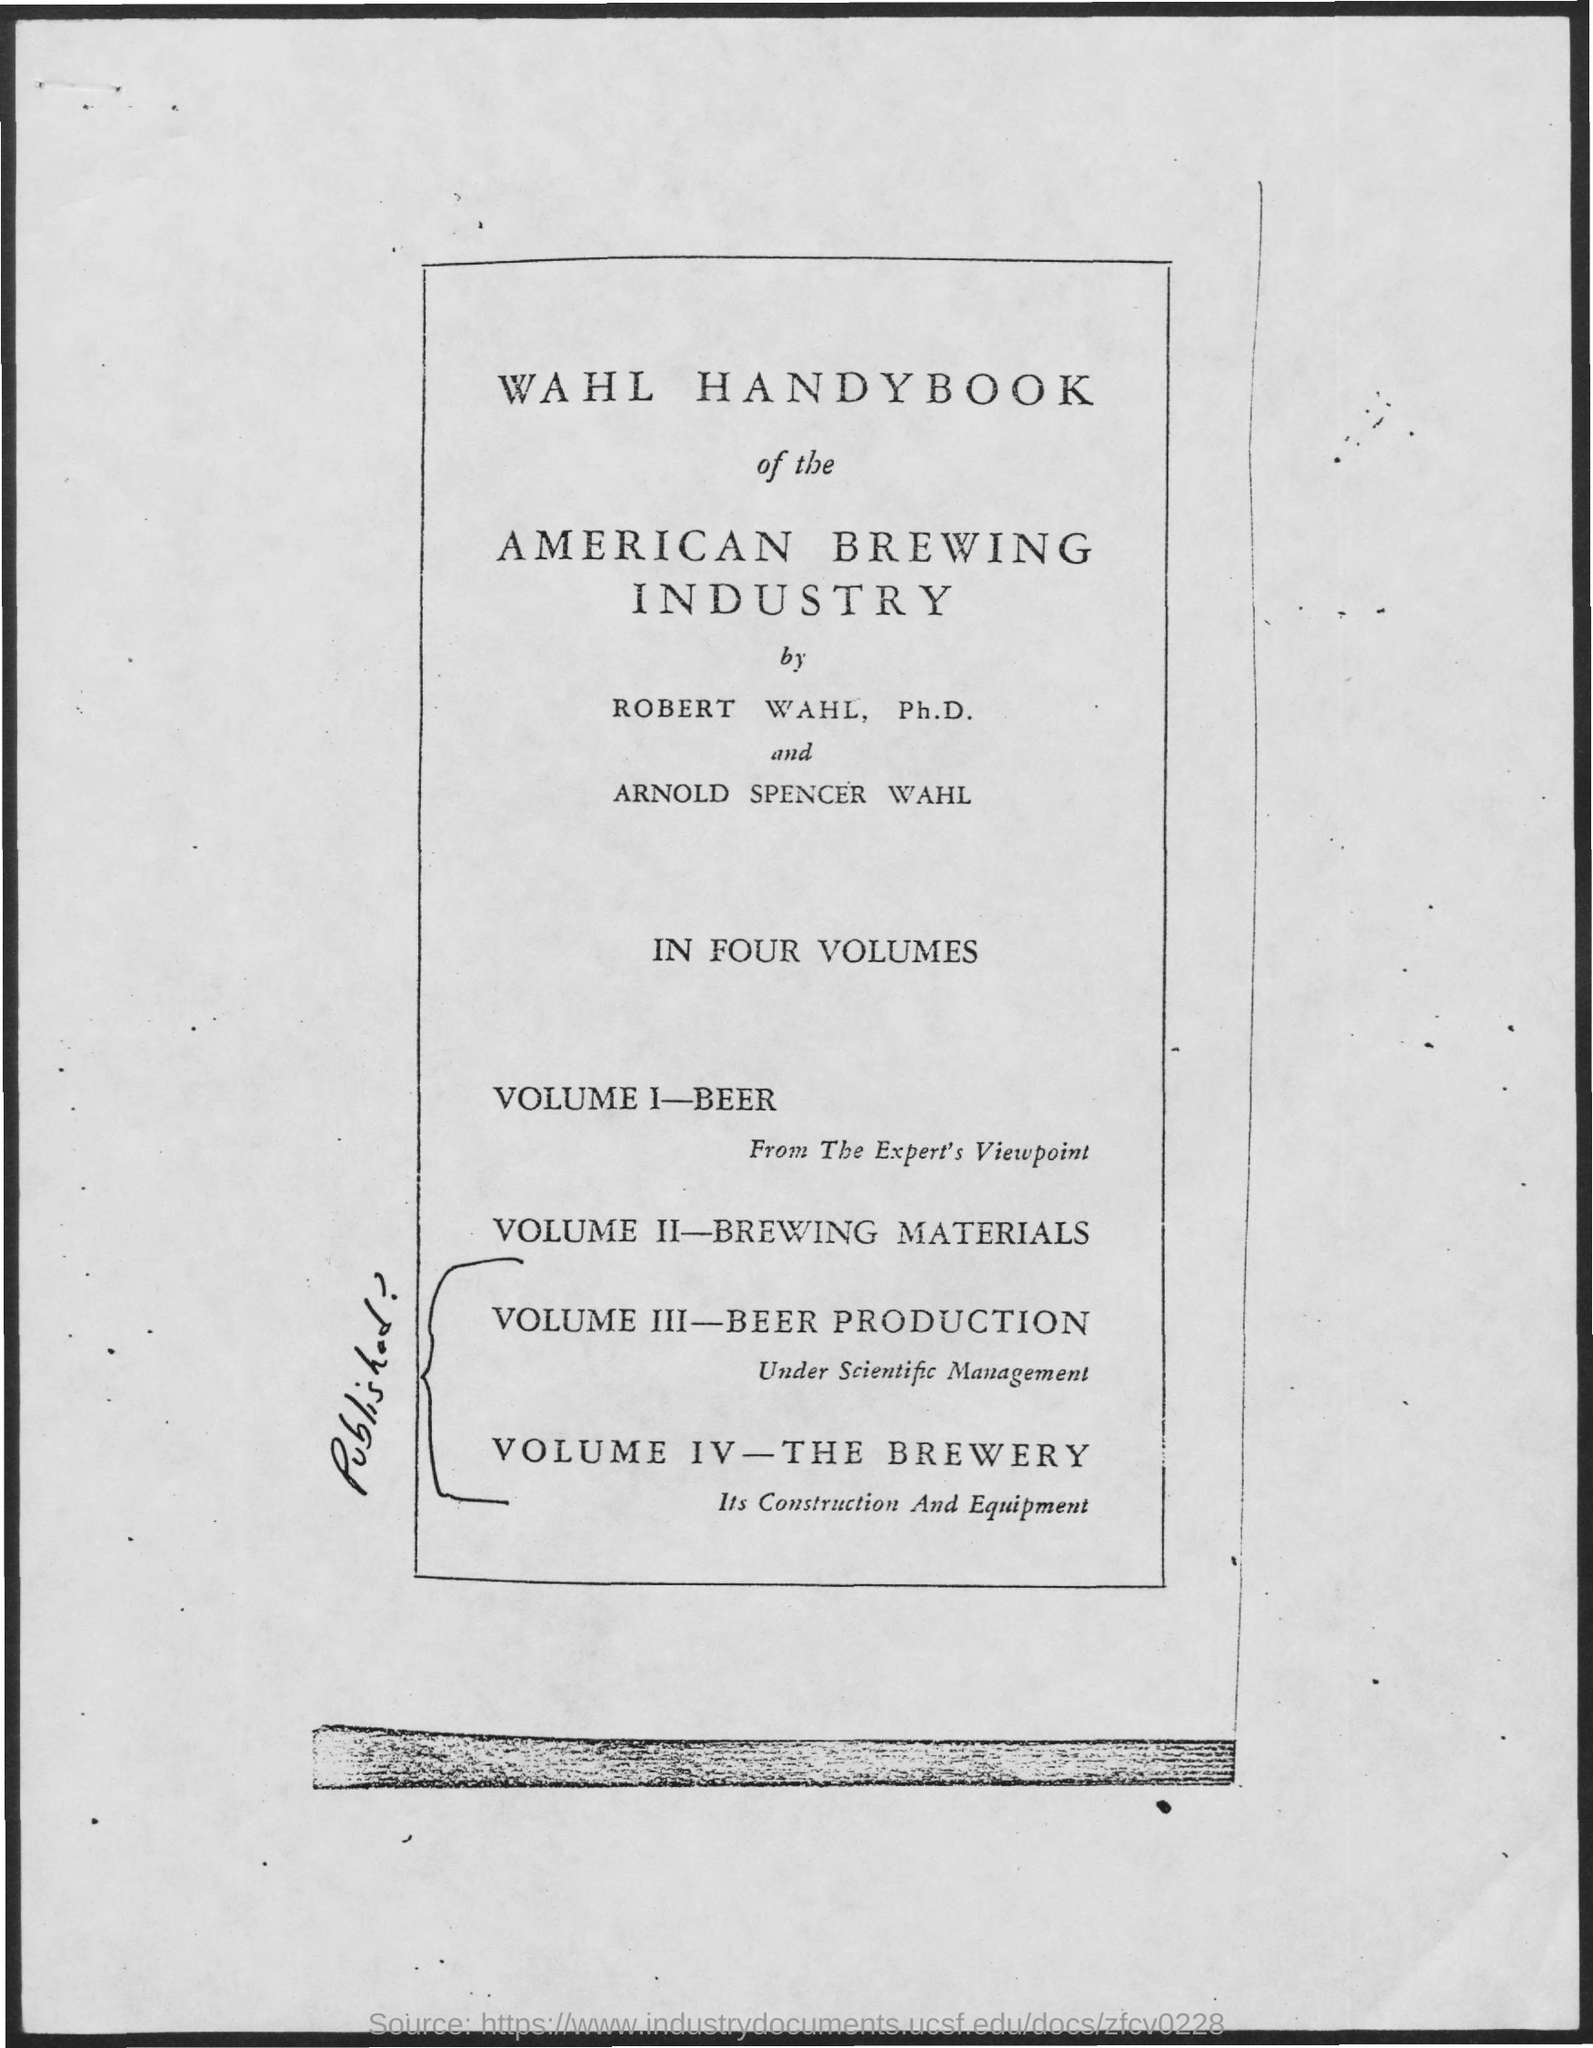What is the name of the industry mentioned ?
Make the answer very short. American Brewing Industry. 